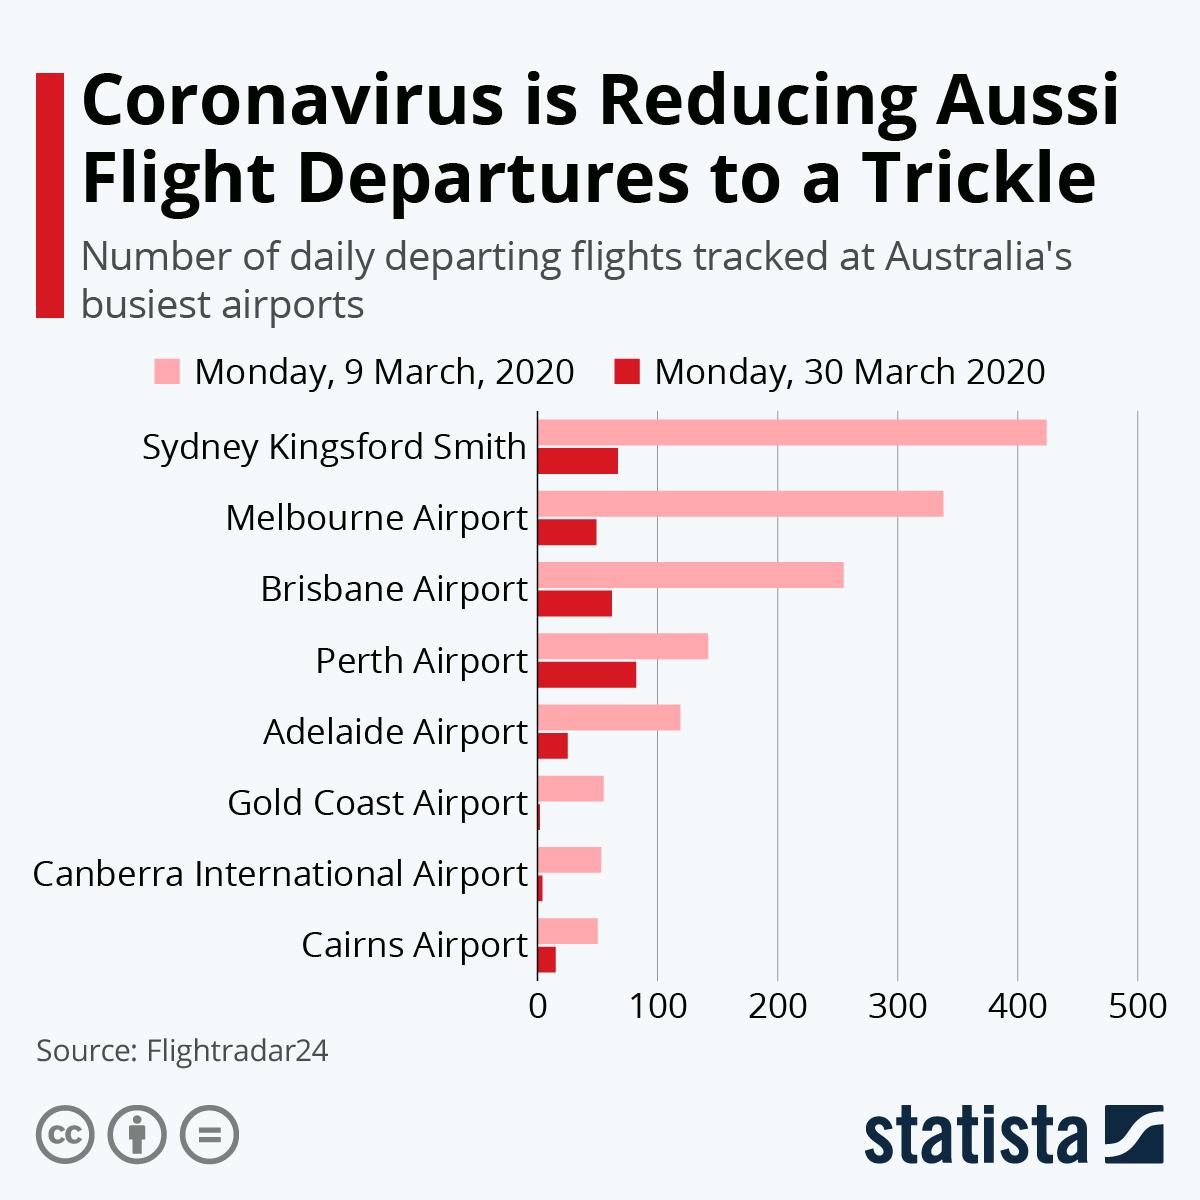Point out several critical features in this image. On March 9th, 2020, Melbourne Airport was the second-busiest airport in terms of the number of flights that departed from it. On March 9th, 2020, the third highest number of flights departed from Brisbane Airport. On 30th March 2020, Canberra International Airport witnessed the second lowest number of departures. On March 30th, 2020, Perth Airport recorded the highest number of departures. 